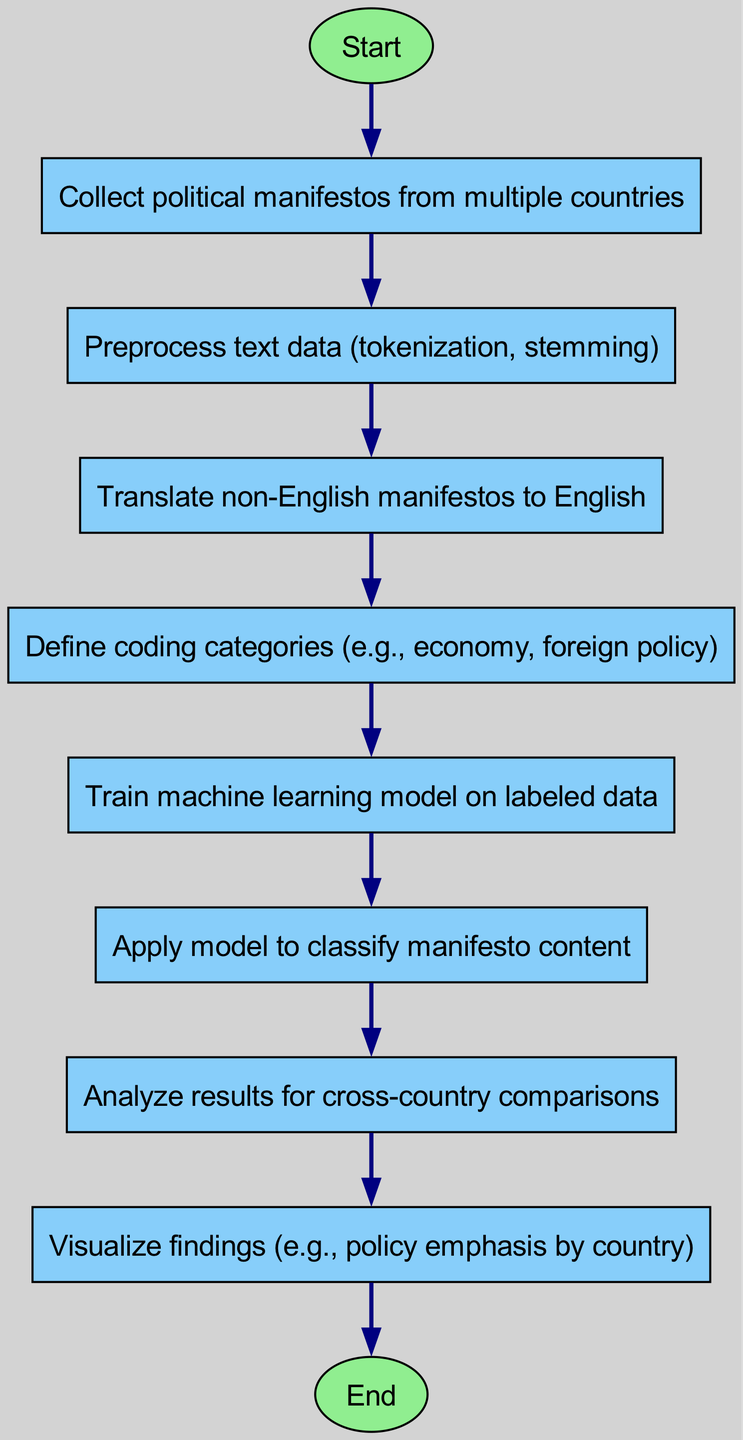What is the first step of the process? The first step of the process is represented by the "Start" node, which indicates the initiation of the procedure.
Answer: Start How many nodes are present in the diagram? The diagram includes a total of ten nodes, each representing a distinct step in the process from "Start" to "End."
Answer: Ten What step comes after preprocessing text data? After preprocessing, the next step is to "Translate non-English manifestos to English," as indicated by the flow direction in the diagram.
Answer: Translate non-English manifestos to English What is the final output of the process? The final output as represented at the end of the flowchart is indicated by the "End" node, indicating the conclusion of the automated content analysis process.
Answer: End Which step involves machine learning? The step that involves machine learning is "Train machine learning model on labeled data," as indicated in the flowchart.
Answer: Train machine learning model on labeled data In which step are coding categories defined? Coding categories are defined in the step labeled "Define coding categories (e.g., economy, foreign policy)," which follows the translation step.
Answer: Define coding categories (e.g., economy, foreign policy) What process step involves analyzing results? The step that involves analyzing the results is labeled "Analyze results for cross-country comparisons," and it follows the application of the model.
Answer: Analyze results for cross-country comparisons How many edges connect the nodes in the diagram? There are nine edges connecting the nodes, representing the flow from one step to the next throughout the process.
Answer: Nine What step happens just before visualizing findings? The step that occurs just before visualizing findings is "Analyze results for cross-country comparisons," as indicated by the flow direction leading to the visualization step.
Answer: Analyze results for cross-country comparisons 